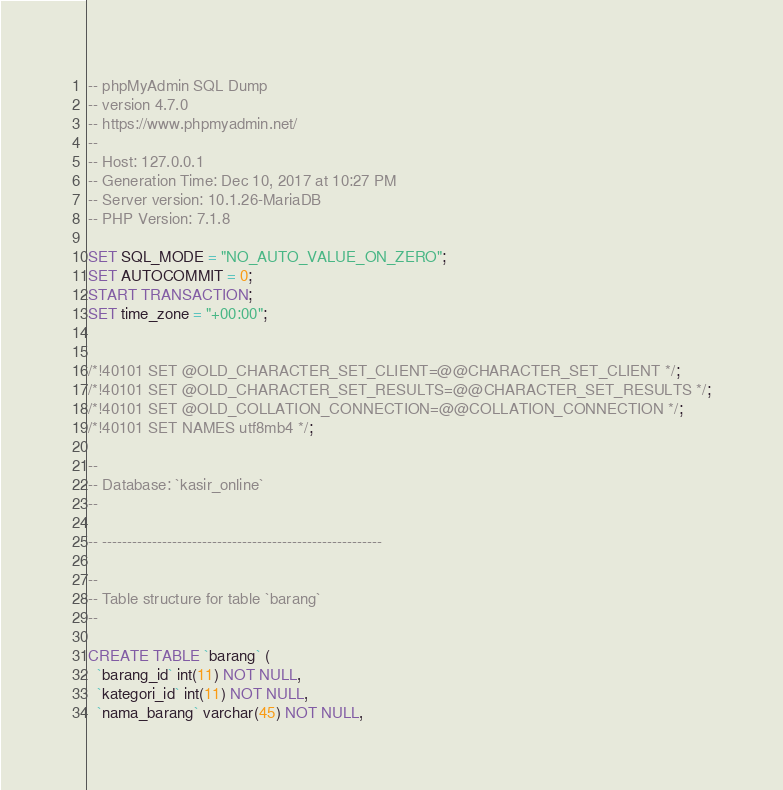<code> <loc_0><loc_0><loc_500><loc_500><_SQL_>-- phpMyAdmin SQL Dump
-- version 4.7.0
-- https://www.phpmyadmin.net/
--
-- Host: 127.0.0.1
-- Generation Time: Dec 10, 2017 at 10:27 PM
-- Server version: 10.1.26-MariaDB
-- PHP Version: 7.1.8

SET SQL_MODE = "NO_AUTO_VALUE_ON_ZERO";
SET AUTOCOMMIT = 0;
START TRANSACTION;
SET time_zone = "+00:00";


/*!40101 SET @OLD_CHARACTER_SET_CLIENT=@@CHARACTER_SET_CLIENT */;
/*!40101 SET @OLD_CHARACTER_SET_RESULTS=@@CHARACTER_SET_RESULTS */;
/*!40101 SET @OLD_COLLATION_CONNECTION=@@COLLATION_CONNECTION */;
/*!40101 SET NAMES utf8mb4 */;

--
-- Database: `kasir_online`
--

-- --------------------------------------------------------

--
-- Table structure for table `barang`
--

CREATE TABLE `barang` (
  `barang_id` int(11) NOT NULL,
  `kategori_id` int(11) NOT NULL,
  `nama_barang` varchar(45) NOT NULL,</code> 